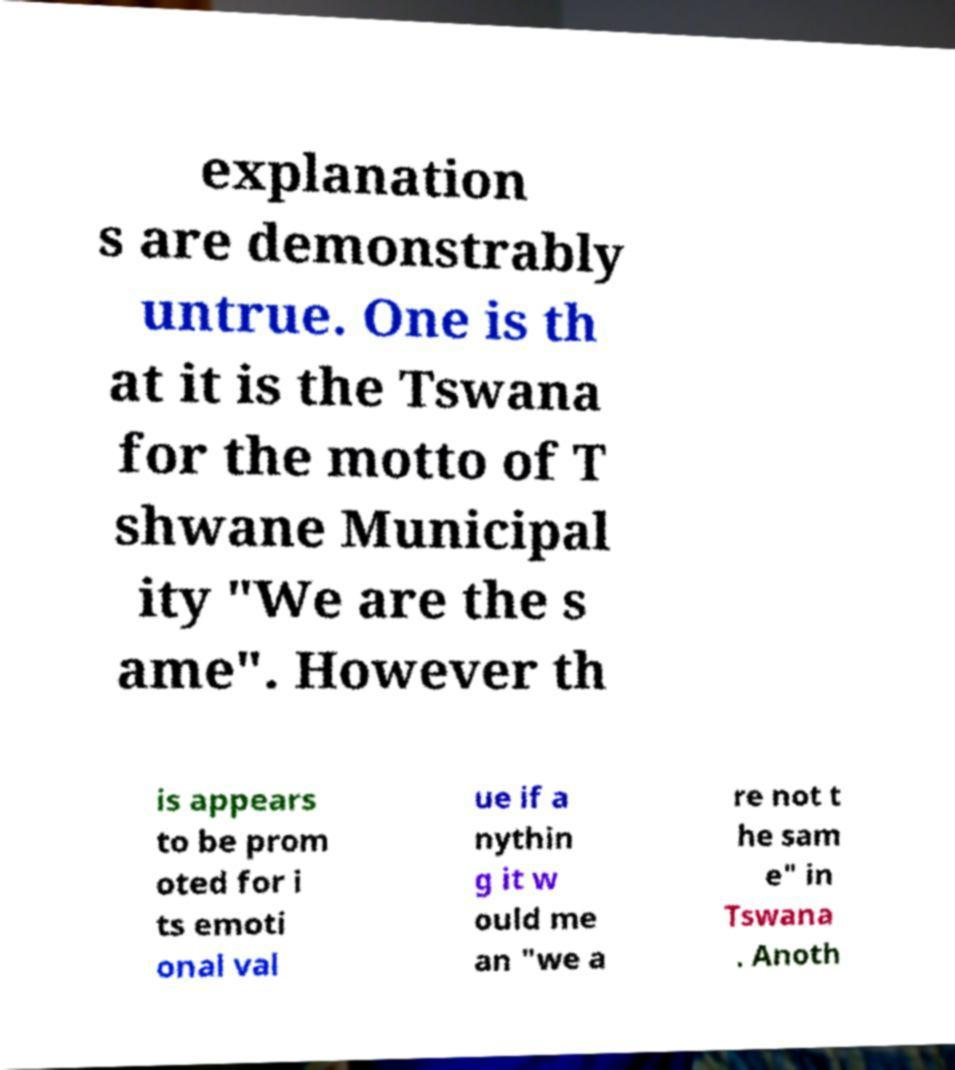I need the written content from this picture converted into text. Can you do that? explanation s are demonstrably untrue. One is th at it is the Tswana for the motto of T shwane Municipal ity "We are the s ame". However th is appears to be prom oted for i ts emoti onal val ue if a nythin g it w ould me an "we a re not t he sam e" in Tswana . Anoth 